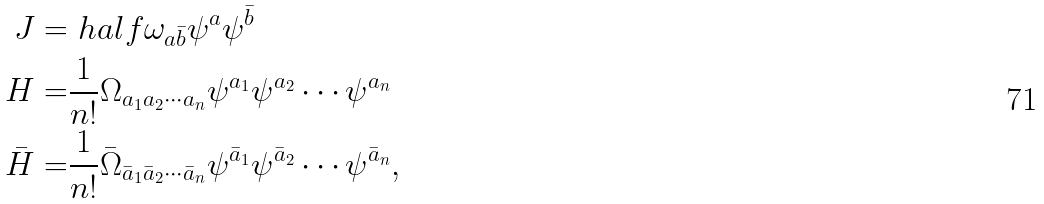<formula> <loc_0><loc_0><loc_500><loc_500>J = & \ h a l f \omega _ { a \bar { b } } \psi ^ { a } \psi ^ { \bar { b } } \\ H = & \frac { 1 } { n ! } \Omega _ { a _ { 1 } a _ { 2 } \cdots a _ { n } } \psi ^ { a _ { 1 } } \psi ^ { a _ { 2 } } \cdots \psi ^ { a _ { n } } \\ \bar { H } = & \frac { 1 } { n ! } \bar { \Omega } _ { \bar { a } _ { 1 } \bar { a } _ { 2 } \cdots \bar { a } _ { n } } \psi ^ { \bar { a } _ { 1 } } \psi ^ { \bar { a } _ { 2 } } \cdots \psi ^ { \bar { a } _ { n } } ,</formula> 